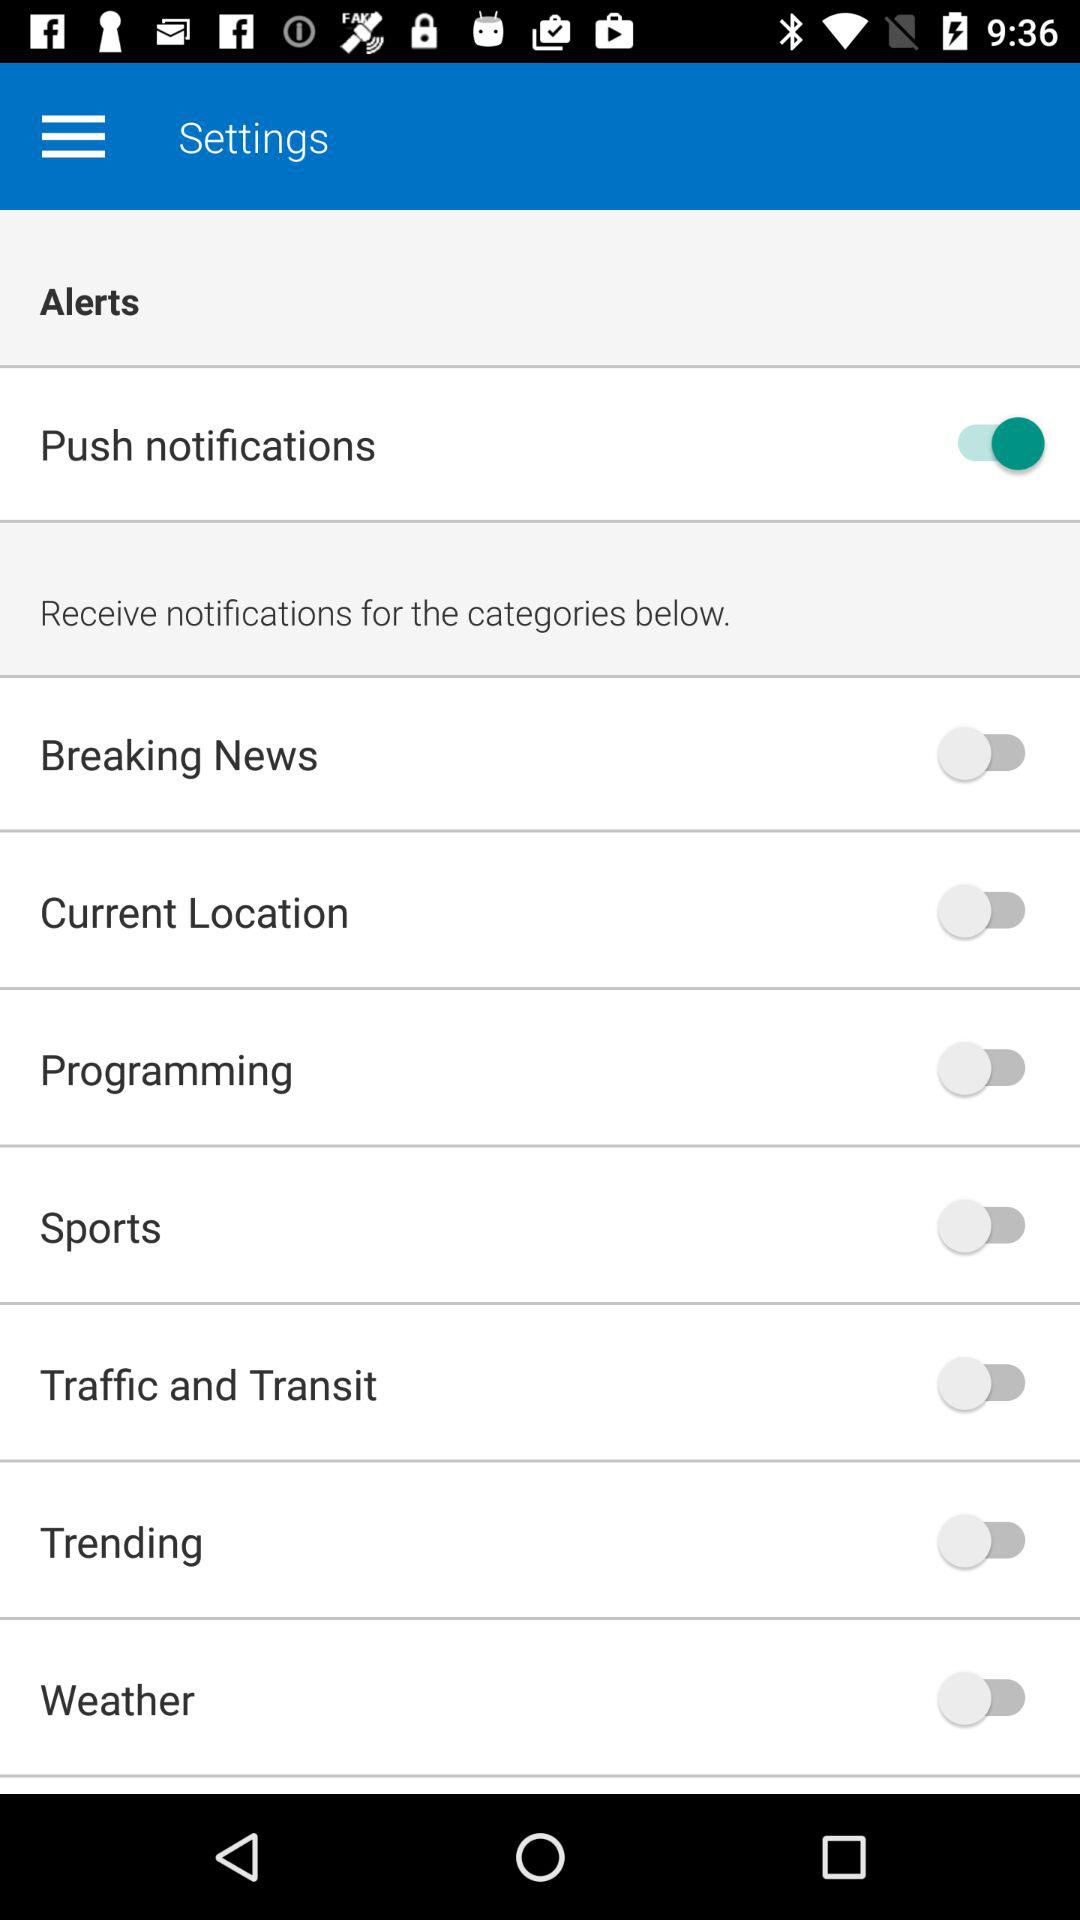Is push notification enabled?
When the provided information is insufficient, respond with <no answer>. <no answer> 